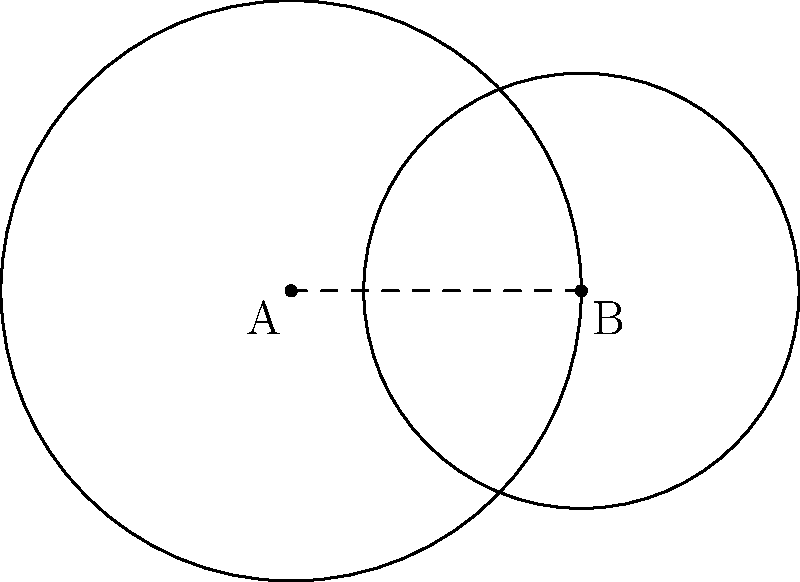As a crime prevention counselor, you're analyzing a neighborhood crime map. Two circular zones of concern overlap, as shown in the diagram. Zone A has a radius of 2 units, and Zone B has a radius of 1.5 units. The centers of these zones are 2 units apart. Calculate the area of the overlapping region to determine the highest risk area for targeted intervention. Round your answer to two decimal places. To find the area of the overlapping region, we'll use the formula for the area of intersection of two circles:

1) First, calculate the distance $d$ between the centers:
   $d = 2$ units (given)

2) Use the formula for the area of intersection:
   $A = r_1^2 \arccos(\frac{d^2 + r_1^2 - r_2^2}{2dr_1}) + r_2^2 \arccos(\frac{d^2 + r_2^2 - r_1^2}{2dr_2}) - \frac{1}{2}\sqrt{(-d+r_1+r_2)(d+r_1-r_2)(d-r_1+r_2)(d+r_1+r_2)}$

   Where $r_1 = 2$ and $r_2 = 1.5$

3) Substitute the values:
   $A = 2^2 \arccos(\frac{2^2 + 2^2 - 1.5^2}{2 \cdot 2 \cdot 2}) + 1.5^2 \arccos(\frac{2^2 + 1.5^2 - 2^2}{2 \cdot 2 \cdot 1.5}) - \frac{1}{2}\sqrt{(-2+2+1.5)(2+2-1.5)(2-2+1.5)(2+2+1.5)}$

4) Simplify:
   $A = 4 \arccos(0.71875) + 2.25 \arccos(0.40625) - \frac{1}{2}\sqrt{1.5 \cdot 2.5 \cdot 1.5 \cdot 5.5}$

5) Calculate:
   $A \approx 4 \cdot 0.7754 + 2.25 \cdot 1.1648 - 0.5 \cdot 3.5460$
   $A \approx 3.1016 + 2.6208 - 1.7730$
   $A \approx 3.9494$

6) Round to two decimal places:
   $A \approx 3.95$ square units
Answer: 3.95 square units 